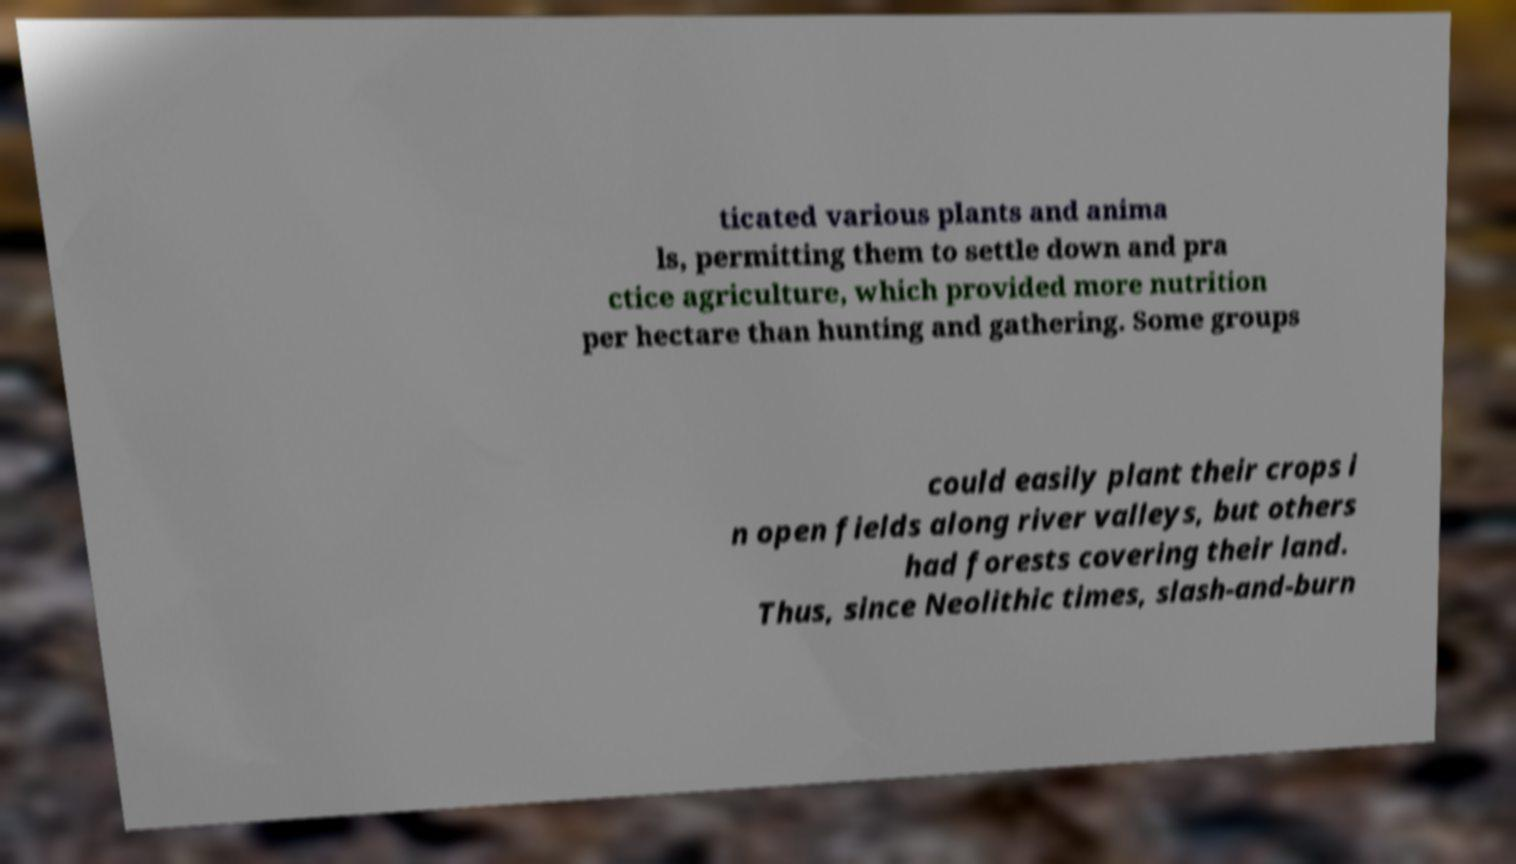I need the written content from this picture converted into text. Can you do that? ticated various plants and anima ls, permitting them to settle down and pra ctice agriculture, which provided more nutrition per hectare than hunting and gathering. Some groups could easily plant their crops i n open fields along river valleys, but others had forests covering their land. Thus, since Neolithic times, slash-and-burn 